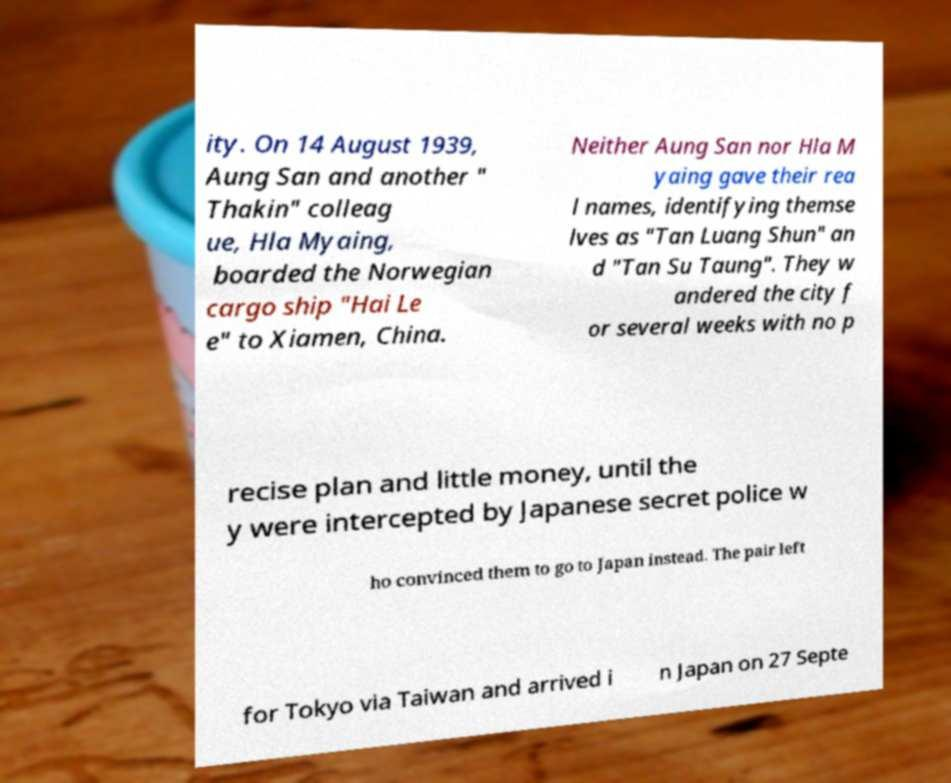Can you accurately transcribe the text from the provided image for me? ity. On 14 August 1939, Aung San and another " Thakin" colleag ue, Hla Myaing, boarded the Norwegian cargo ship "Hai Le e" to Xiamen, China. Neither Aung San nor Hla M yaing gave their rea l names, identifying themse lves as "Tan Luang Shun" an d "Tan Su Taung". They w andered the city f or several weeks with no p recise plan and little money, until the y were intercepted by Japanese secret police w ho convinced them to go to Japan instead. The pair left for Tokyo via Taiwan and arrived i n Japan on 27 Septe 